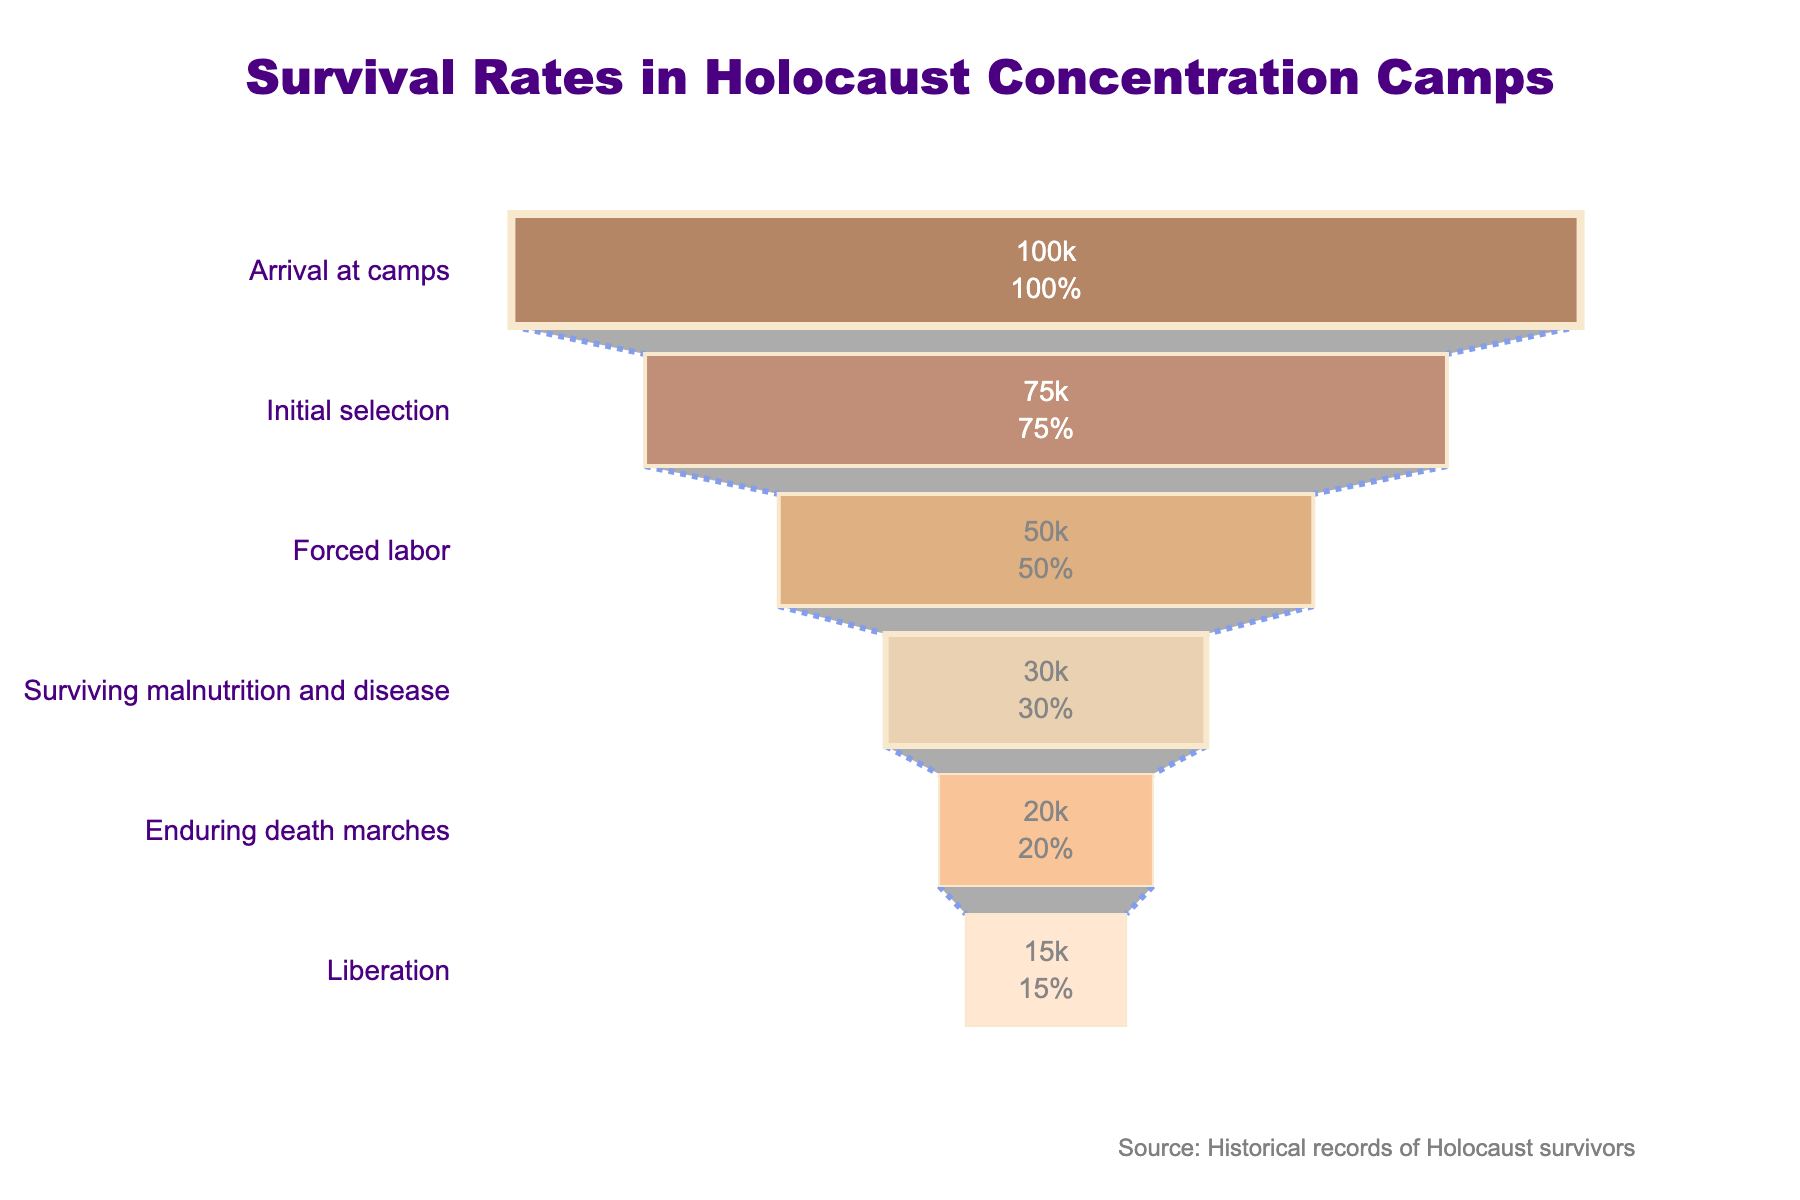What is the title of the funnel chart? The title is displayed at the top of the chart.
Answer: Survival Rates in Holocaust Concentration Camps How many stages are depicted in the funnel chart? The number of stages is indicated by the number of horizontal sections in the chart.
Answer: 6 What is the number of survivors at the initial selection stage? The "Initial selection" stage value is listed inside its section.
Answer: 75,000 Which stage shows the highest number of survivors? By looking at the chart, the stage with the largest section indicates the highest number of survivors, which is the first stage.
Answer: Arrival at camps What percentage of arrivals survived until the liberation stage? The value and percentage are indicated inside the last section of the funnel chart.
Answer: 15,000 survivors, 15% of initial What is the difference in survivor count between forced labor and surviving malnutrition and disease? Subtract the number of survivors at "Surviving malnutrition and disease" from "Forced labor".
Answer: 50,000 - 30,000 = 20,000 By what percentage does the number of survivors decrease from the initial selection to forced labor? Calculate the percentage decrease from 75,000 to 50,000. The percentage decrease is (\(75,000 - 50,000\) / 75,000) * 100.
Answer: 33.33% What stage has the smallest number of survivors, and how many are there? The smallest section at the end of the funnel chart indicates both the smallest number and the stage name.
Answer: Liberation, 15,000 How many survivors were lost between enduring death marches and the liberation? Subtract the number of survivors at "Liberation" from "Enduring death marches".
Answer: 20,000 - 15,000 = 5,000 In which stage is the loss of survivors the most significant, measured by the number of people? Identify the largest numerical difference between any two consecutive stages.
Answer: Arrival at camps to Initial selection, 25,000 survivors lost 